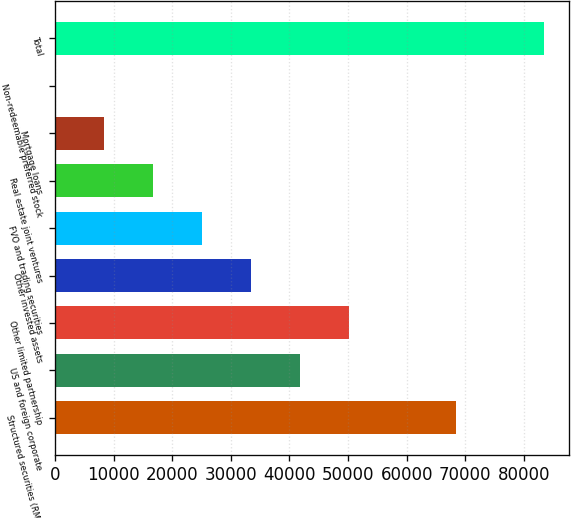Convert chart. <chart><loc_0><loc_0><loc_500><loc_500><bar_chart><fcel>Structured securities (RMBS<fcel>US and foreign corporate<fcel>Other limited partnership<fcel>Other invested assets<fcel>FVO and trading securities<fcel>Real estate joint ventures<fcel>Mortgage loans<fcel>Non-redeemable preferred stock<fcel>Total<nl><fcel>68427<fcel>41765.5<fcel>50110.4<fcel>33420.6<fcel>25075.7<fcel>16730.8<fcel>8385.9<fcel>41<fcel>83490<nl></chart> 